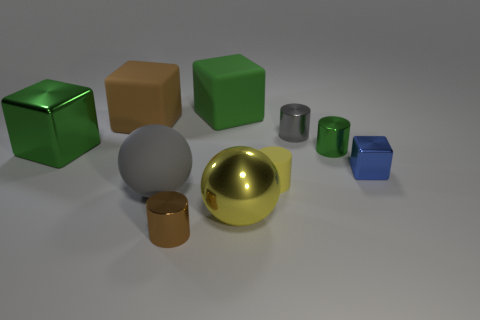What shape is the small thing that is the same color as the big matte sphere?
Give a very brief answer. Cylinder. How many objects are either green blocks that are left of the brown rubber block or tiny green cylinders?
Ensure brevity in your answer.  2. Do the blue thing and the yellow shiny thing have the same size?
Your answer should be compact. No. There is a cube right of the tiny green cylinder; what is its color?
Your answer should be very brief. Blue. The blue block that is made of the same material as the brown cylinder is what size?
Provide a succinct answer. Small. There is a brown rubber cube; does it have the same size as the rubber ball behind the tiny brown cylinder?
Make the answer very short. Yes. What is the material of the block that is on the right side of the tiny yellow thing?
Your answer should be compact. Metal. There is a small shiny cylinder that is in front of the large gray matte object; what number of metal cylinders are left of it?
Ensure brevity in your answer.  0. Is there a tiny cyan thing of the same shape as the large brown object?
Offer a terse response. No. There is a green thing to the right of the large yellow thing; does it have the same size as the gray object that is behind the small blue metal object?
Make the answer very short. Yes. 